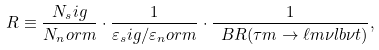<formula> <loc_0><loc_0><loc_500><loc_500>R \equiv \frac { N _ { s } i g } { N _ { n } o r m } \cdot \frac { 1 } { \varepsilon _ { s } i g / \varepsilon _ { n } o r m } \cdot \frac { 1 } { \ B R ( \tau m \to \ell m \nu l b \nu t ) } ,</formula> 